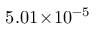<formula> <loc_0><loc_0><loc_500><loc_500>5 . 0 1 \, \times \, 1 0 ^ { - 5 }</formula> 